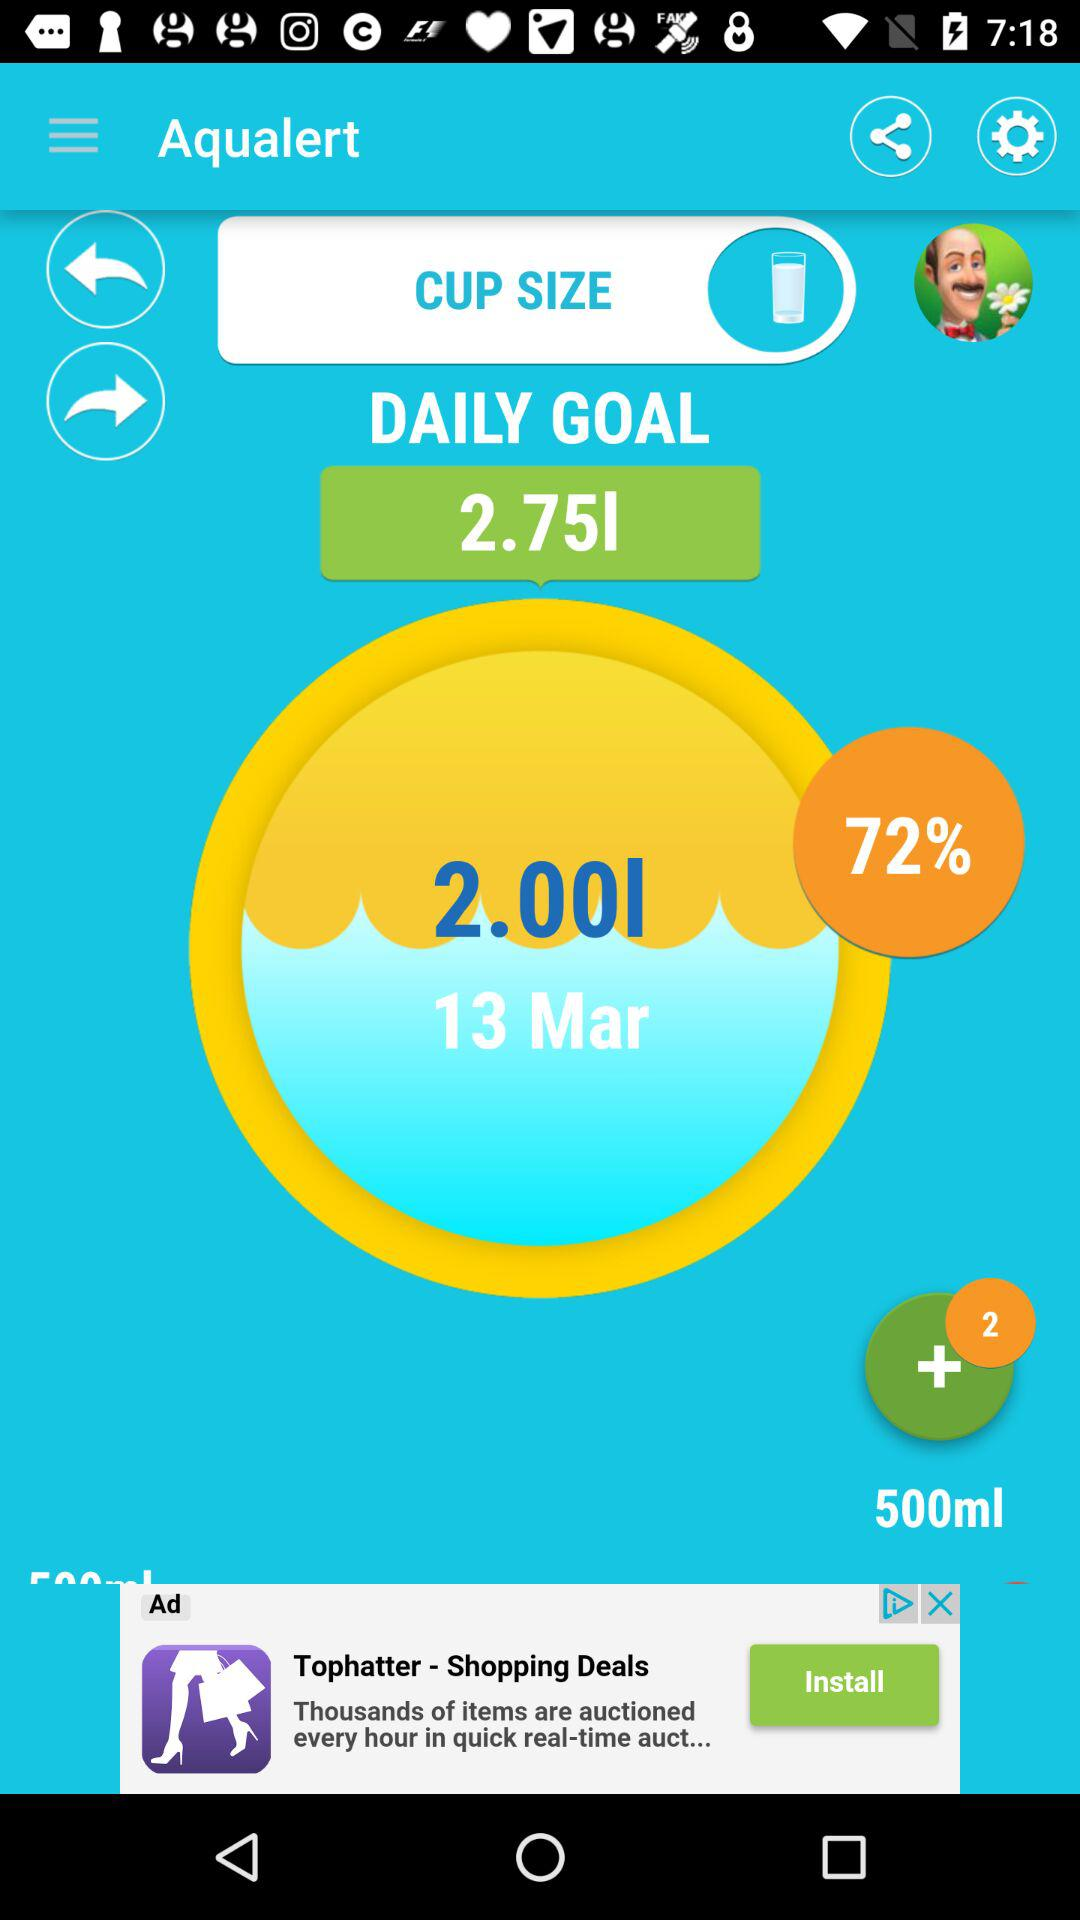What is the name of the application? The name of the application is "Aqualert". 